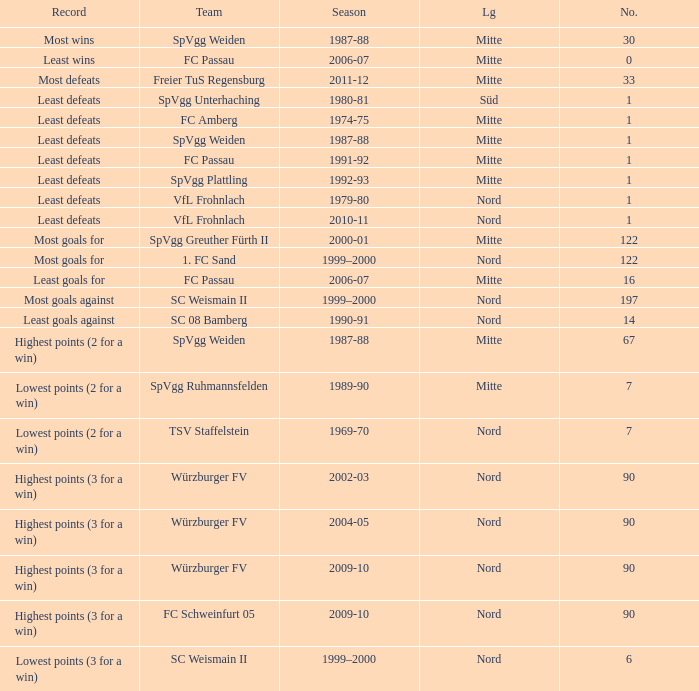What league has a number less than 122, and least wins as the record? Mitte. 